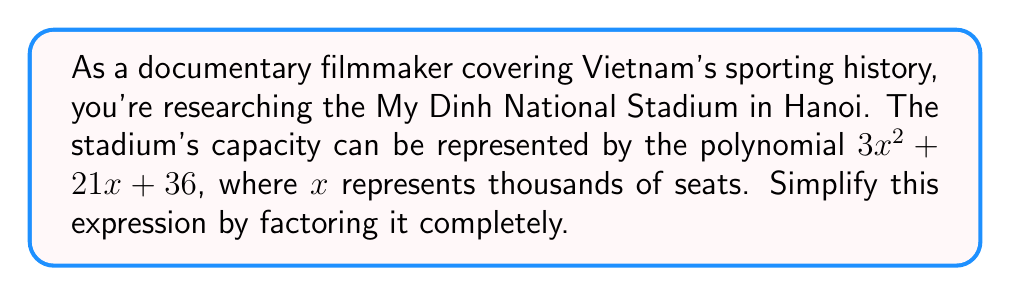Can you solve this math problem? Let's approach this step-by-step:

1) The polynomial we need to factor is $3x^2 + 21x + 36$.

2) First, let's check if there's a common factor:
   $GCD(3x^2, 21x, 36) = 3$
   
   So we can factor out 3: $3(x^2 + 7x + 12)$

3) Now we need to factor the quadratic expression inside the parentheses: $x^2 + 7x + 12$

4) We're looking for two numbers that multiply to give 12 and add up to 7.
   These numbers are 3 and 4.

5) So we can rewrite the quadratic as: $(x + 3)(x + 4)$

6) Putting it all together, our factored expression is:

   $$3(x + 3)(x + 4)$$

This factored form represents the stadium's capacity in thousands of seats, with each factor potentially corresponding to different sections or levels of the stadium.
Answer: $3(x + 3)(x + 4)$ 